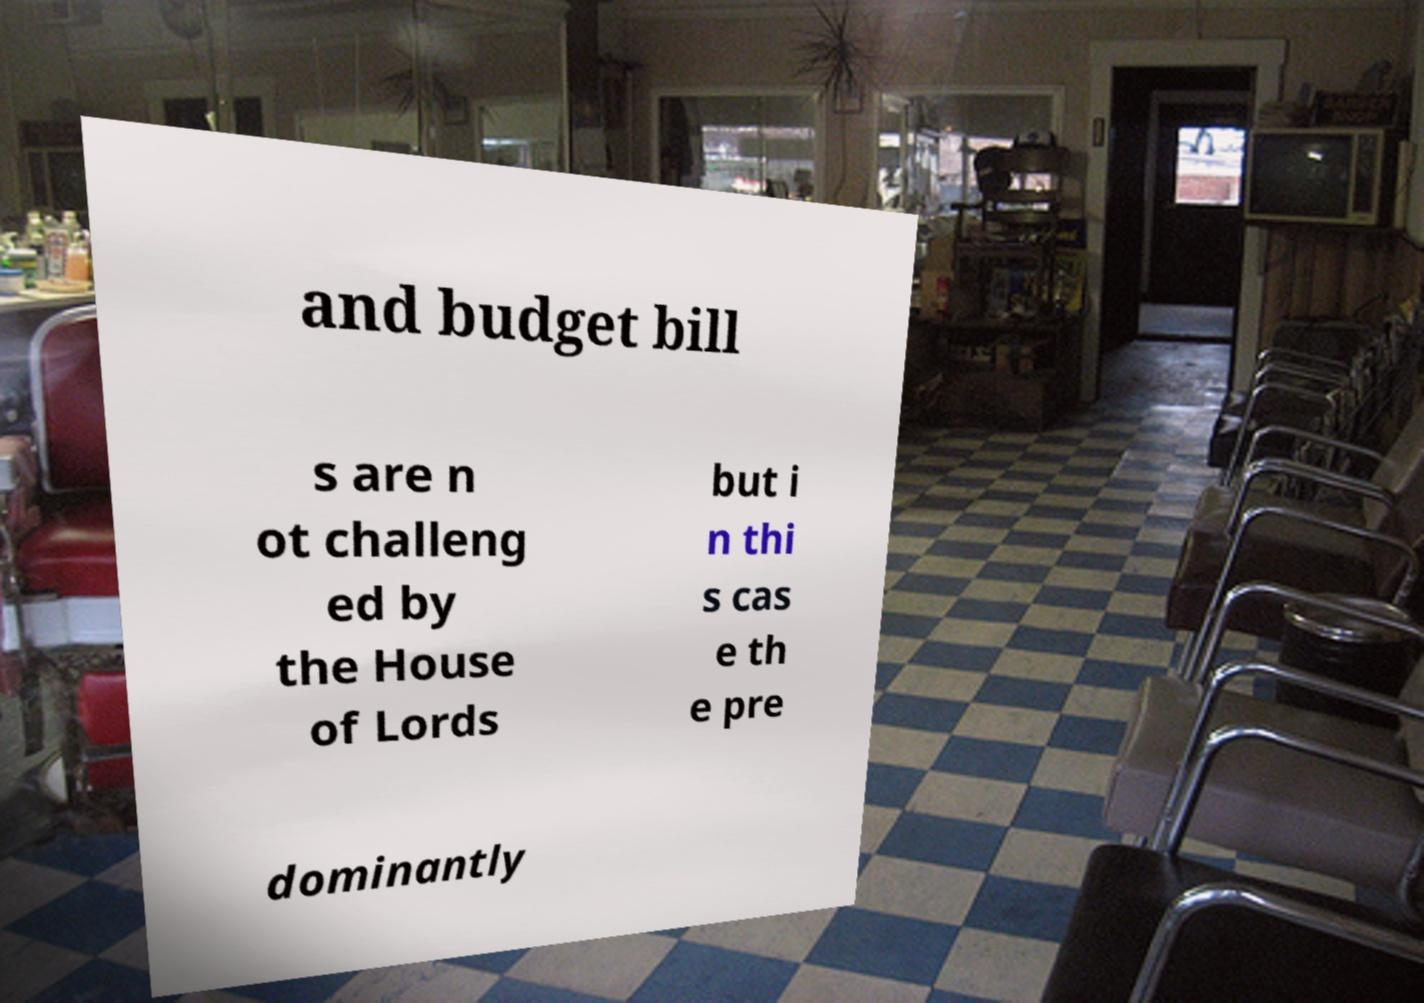What messages or text are displayed in this image? I need them in a readable, typed format. and budget bill s are n ot challeng ed by the House of Lords but i n thi s cas e th e pre dominantly 